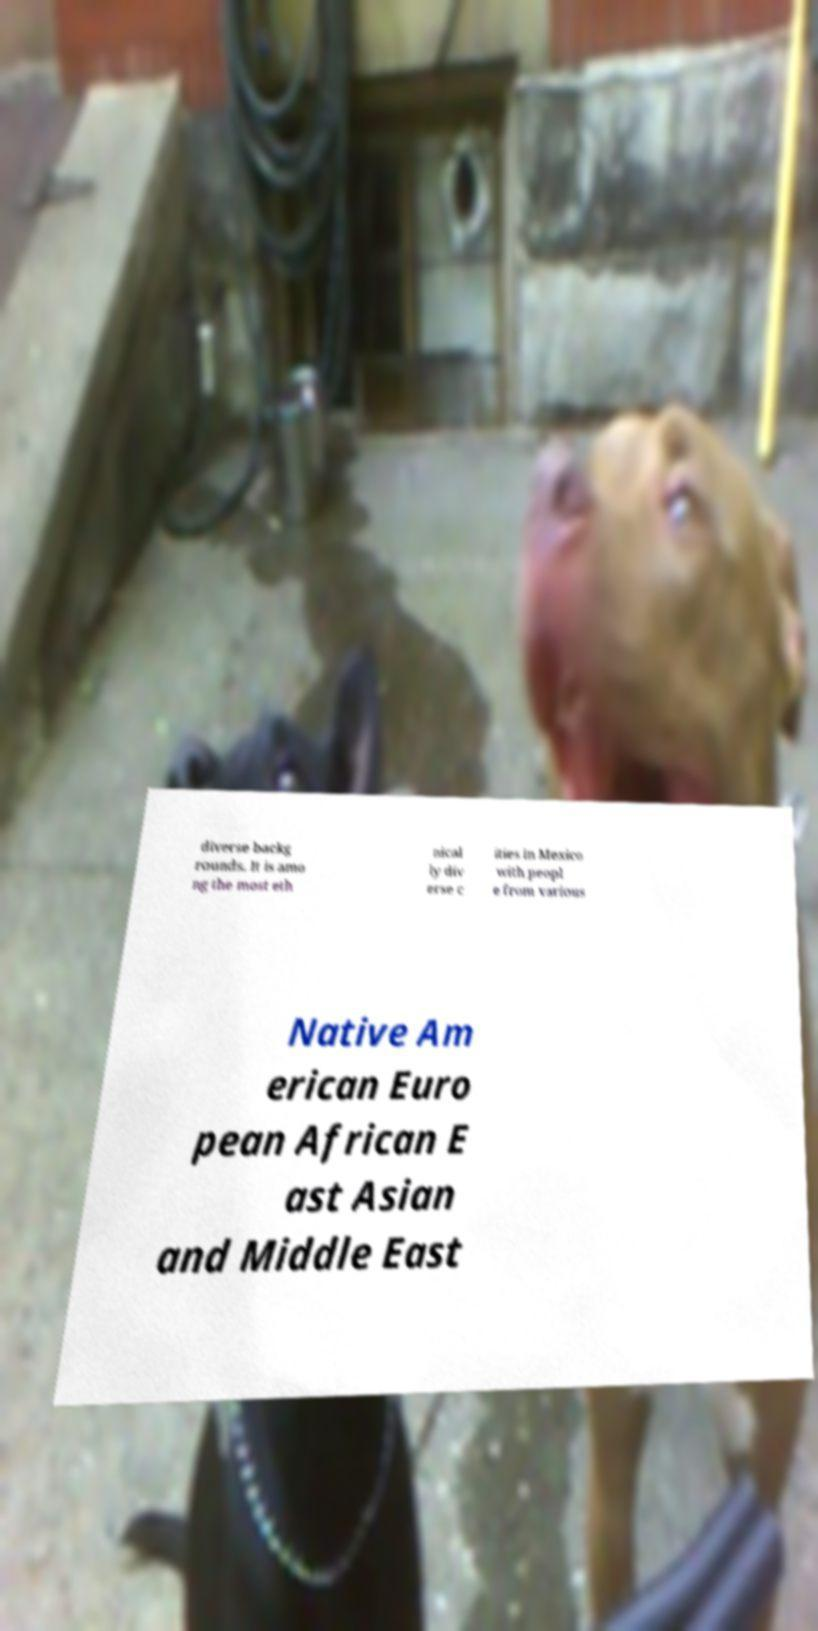Please identify and transcribe the text found in this image. diverse backg rounds. It is amo ng the most eth nical ly div erse c ities in Mexico with peopl e from various Native Am erican Euro pean African E ast Asian and Middle East 